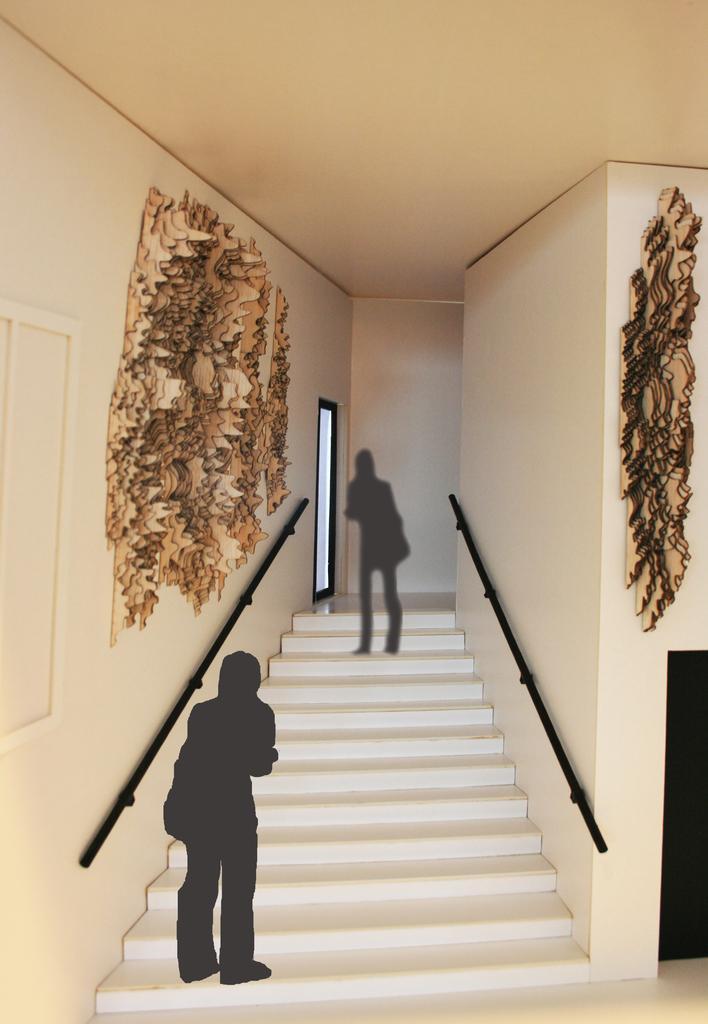Can you describe this image briefly? In this picture I can see the inside view of a building and I see the stairs in front, on which there are black color things and I see the brown color things on the walls. 